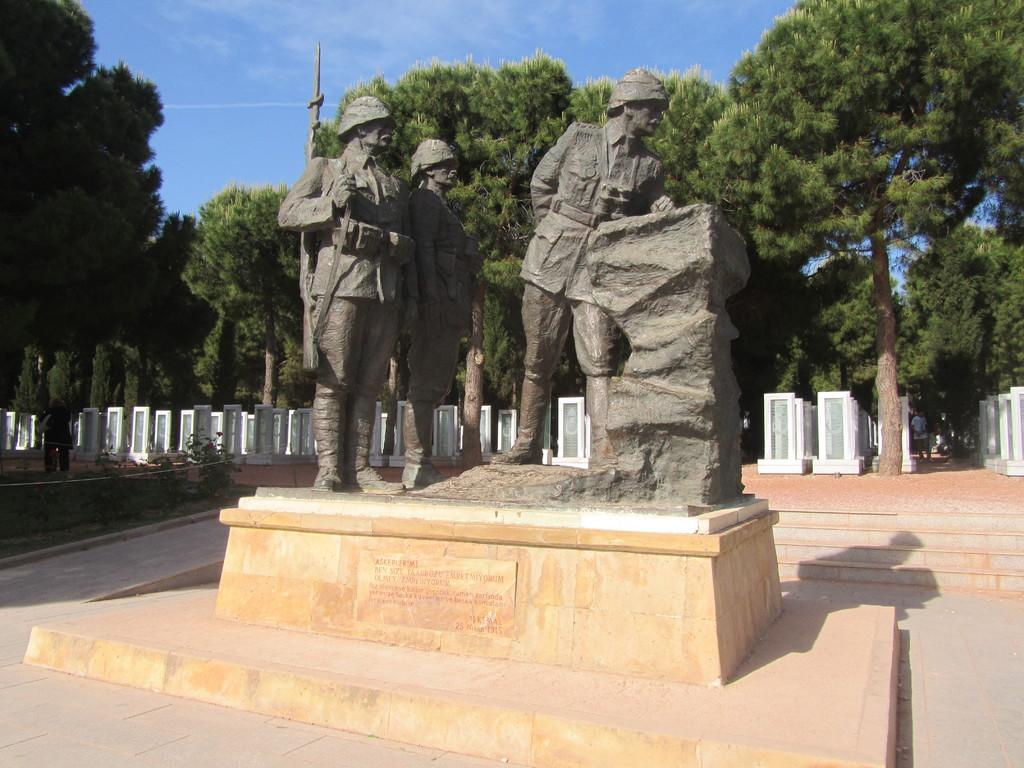What is the main subject in the center of the image? There are sculptures in the center of the image. What is located at the bottom of the image? There is a pedestal at the bottom of the image. What can be seen in the background of the image? There are trees and blocks in the background of the image. What is visible at the top of the image? The sky is visible at the top of the image. What type of pancake is being used to draw attention to the sculptures in the image? There is no pancake present in the image, and therefore it cannot be used to draw attention to the sculptures. 